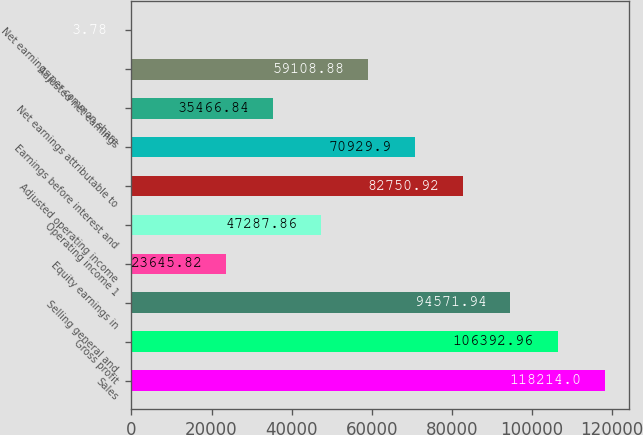Convert chart to OTSL. <chart><loc_0><loc_0><loc_500><loc_500><bar_chart><fcel>Sales<fcel>Gross profit<fcel>Selling general and<fcel>Equity earnings in<fcel>Operating income 1<fcel>Adjusted operating income<fcel>Earnings before interest and<fcel>Net earnings attributable to<fcel>Adjusted net earnings<fcel>Net earnings per common share<nl><fcel>118214<fcel>106393<fcel>94571.9<fcel>23645.8<fcel>47287.9<fcel>82750.9<fcel>70929.9<fcel>35466.8<fcel>59108.9<fcel>3.78<nl></chart> 